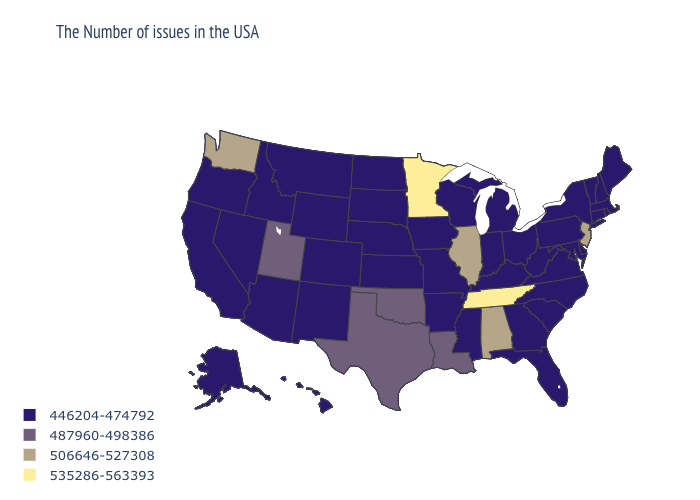Name the states that have a value in the range 535286-563393?
Be succinct. Tennessee, Minnesota. What is the highest value in the USA?
Concise answer only. 535286-563393. What is the lowest value in the USA?
Concise answer only. 446204-474792. Does Louisiana have the lowest value in the USA?
Short answer required. No. What is the highest value in the USA?
Give a very brief answer. 535286-563393. Name the states that have a value in the range 487960-498386?
Keep it brief. Louisiana, Oklahoma, Texas, Utah. Which states have the lowest value in the South?
Concise answer only. Delaware, Maryland, Virginia, North Carolina, South Carolina, West Virginia, Florida, Georgia, Kentucky, Mississippi, Arkansas. Is the legend a continuous bar?
Write a very short answer. No. What is the highest value in the West ?
Keep it brief. 506646-527308. Name the states that have a value in the range 487960-498386?
Keep it brief. Louisiana, Oklahoma, Texas, Utah. What is the value of Hawaii?
Concise answer only. 446204-474792. What is the lowest value in states that border Tennessee?
Give a very brief answer. 446204-474792. What is the lowest value in the MidWest?
Concise answer only. 446204-474792. Which states have the lowest value in the West?
Answer briefly. Wyoming, Colorado, New Mexico, Montana, Arizona, Idaho, Nevada, California, Oregon, Alaska, Hawaii. What is the highest value in states that border Delaware?
Give a very brief answer. 506646-527308. 